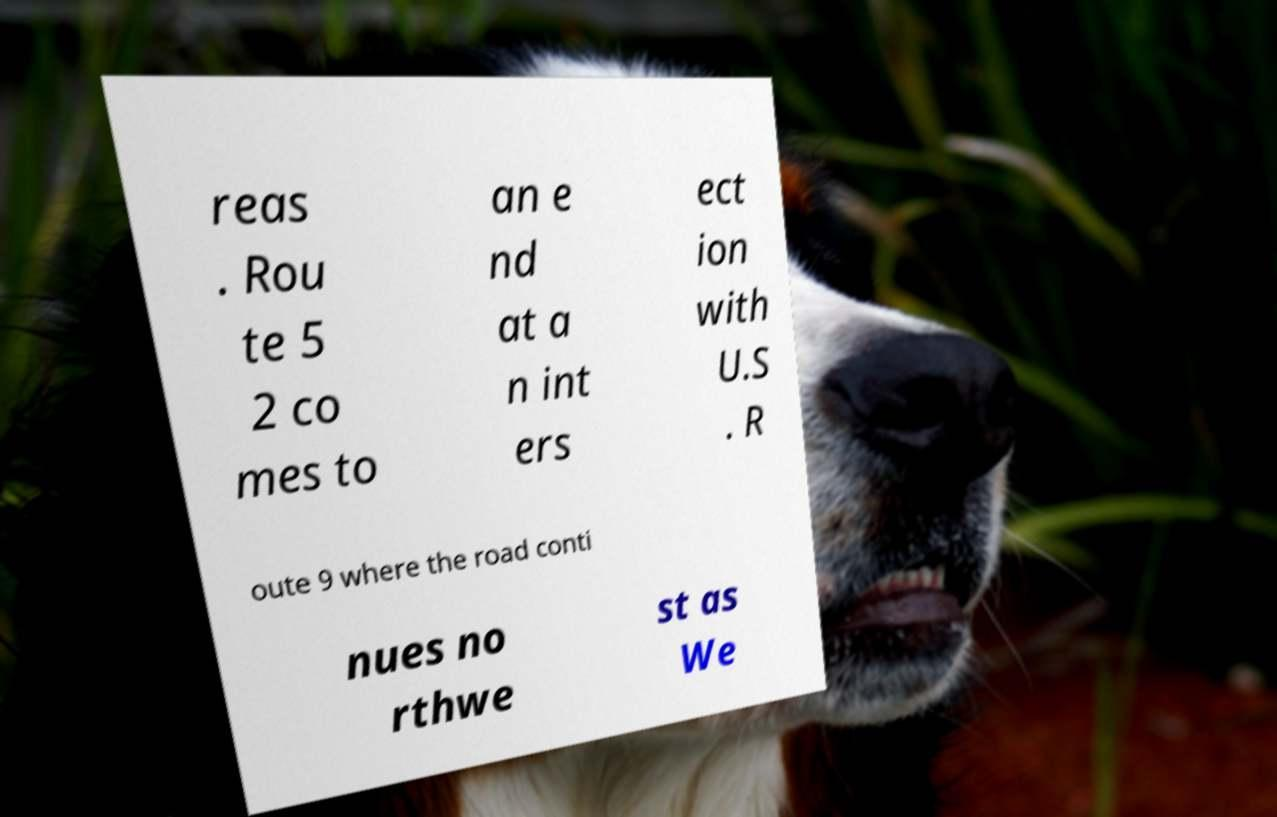Please read and relay the text visible in this image. What does it say? reas . Rou te 5 2 co mes to an e nd at a n int ers ect ion with U.S . R oute 9 where the road conti nues no rthwe st as We 